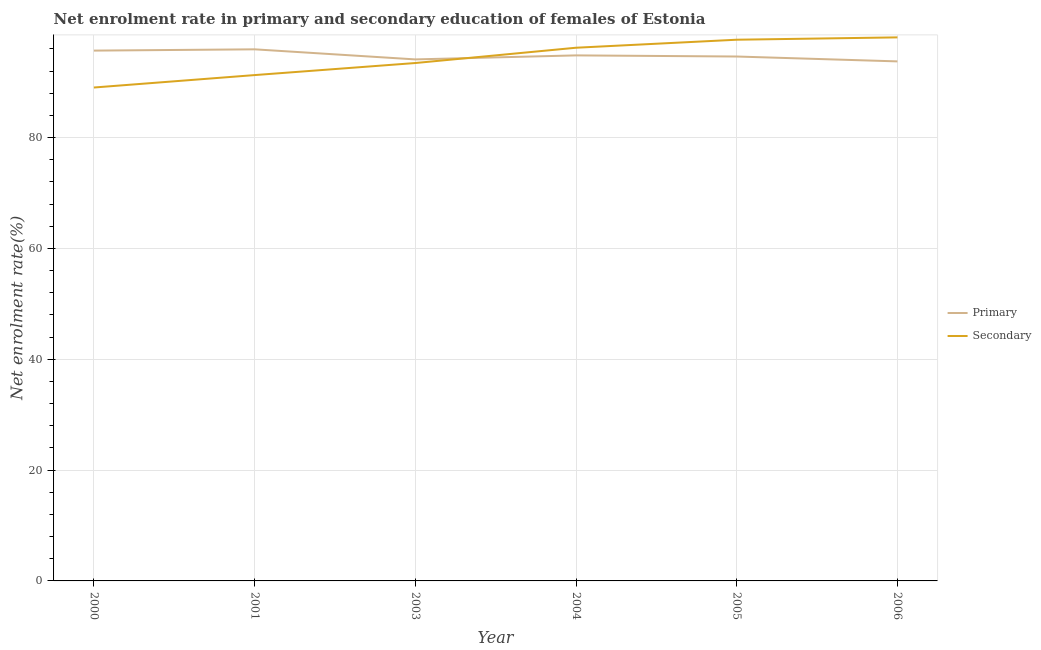How many different coloured lines are there?
Offer a terse response. 2. What is the enrollment rate in secondary education in 2004?
Give a very brief answer. 96.22. Across all years, what is the maximum enrollment rate in primary education?
Your response must be concise. 95.94. Across all years, what is the minimum enrollment rate in secondary education?
Your response must be concise. 89.04. In which year was the enrollment rate in secondary education minimum?
Offer a terse response. 2000. What is the total enrollment rate in secondary education in the graph?
Your response must be concise. 565.78. What is the difference between the enrollment rate in primary education in 2001 and that in 2003?
Offer a very short reply. 1.82. What is the difference between the enrollment rate in primary education in 2004 and the enrollment rate in secondary education in 2003?
Your response must be concise. 1.38. What is the average enrollment rate in primary education per year?
Your response must be concise. 94.83. In the year 2001, what is the difference between the enrollment rate in primary education and enrollment rate in secondary education?
Make the answer very short. 4.65. In how many years, is the enrollment rate in secondary education greater than 48 %?
Keep it short and to the point. 6. What is the ratio of the enrollment rate in secondary education in 2001 to that in 2004?
Your answer should be compact. 0.95. What is the difference between the highest and the second highest enrollment rate in primary education?
Provide a succinct answer. 0.23. What is the difference between the highest and the lowest enrollment rate in secondary education?
Keep it short and to the point. 9.05. In how many years, is the enrollment rate in secondary education greater than the average enrollment rate in secondary education taken over all years?
Keep it short and to the point. 3. Does the enrollment rate in primary education monotonically increase over the years?
Your answer should be very brief. No. Is the enrollment rate in primary education strictly greater than the enrollment rate in secondary education over the years?
Give a very brief answer. No. How many lines are there?
Your answer should be very brief. 2. How many years are there in the graph?
Your answer should be compact. 6. Does the graph contain any zero values?
Make the answer very short. No. Does the graph contain grids?
Your answer should be compact. Yes. How many legend labels are there?
Provide a succinct answer. 2. What is the title of the graph?
Your answer should be very brief. Net enrolment rate in primary and secondary education of females of Estonia. Does "Electricity" appear as one of the legend labels in the graph?
Your answer should be compact. No. What is the label or title of the X-axis?
Your answer should be compact. Year. What is the label or title of the Y-axis?
Make the answer very short. Net enrolment rate(%). What is the Net enrolment rate(%) in Primary in 2000?
Your answer should be very brief. 95.7. What is the Net enrolment rate(%) of Secondary in 2000?
Your answer should be very brief. 89.04. What is the Net enrolment rate(%) of Primary in 2001?
Offer a very short reply. 95.94. What is the Net enrolment rate(%) of Secondary in 2001?
Your answer should be compact. 91.29. What is the Net enrolment rate(%) in Primary in 2003?
Give a very brief answer. 94.12. What is the Net enrolment rate(%) in Secondary in 2003?
Keep it short and to the point. 93.46. What is the Net enrolment rate(%) in Primary in 2004?
Ensure brevity in your answer.  94.84. What is the Net enrolment rate(%) in Secondary in 2004?
Offer a terse response. 96.22. What is the Net enrolment rate(%) in Primary in 2005?
Make the answer very short. 94.64. What is the Net enrolment rate(%) of Secondary in 2005?
Keep it short and to the point. 97.67. What is the Net enrolment rate(%) of Primary in 2006?
Offer a terse response. 93.76. What is the Net enrolment rate(%) of Secondary in 2006?
Provide a short and direct response. 98.09. Across all years, what is the maximum Net enrolment rate(%) in Primary?
Your answer should be very brief. 95.94. Across all years, what is the maximum Net enrolment rate(%) in Secondary?
Give a very brief answer. 98.09. Across all years, what is the minimum Net enrolment rate(%) of Primary?
Offer a terse response. 93.76. Across all years, what is the minimum Net enrolment rate(%) in Secondary?
Your response must be concise. 89.04. What is the total Net enrolment rate(%) in Primary in the graph?
Provide a short and direct response. 569. What is the total Net enrolment rate(%) in Secondary in the graph?
Give a very brief answer. 565.78. What is the difference between the Net enrolment rate(%) of Primary in 2000 and that in 2001?
Ensure brevity in your answer.  -0.23. What is the difference between the Net enrolment rate(%) of Secondary in 2000 and that in 2001?
Your answer should be very brief. -2.24. What is the difference between the Net enrolment rate(%) of Primary in 2000 and that in 2003?
Your answer should be very brief. 1.59. What is the difference between the Net enrolment rate(%) of Secondary in 2000 and that in 2003?
Your answer should be compact. -4.42. What is the difference between the Net enrolment rate(%) in Primary in 2000 and that in 2004?
Ensure brevity in your answer.  0.86. What is the difference between the Net enrolment rate(%) of Secondary in 2000 and that in 2004?
Provide a succinct answer. -7.18. What is the difference between the Net enrolment rate(%) in Primary in 2000 and that in 2005?
Offer a very short reply. 1.07. What is the difference between the Net enrolment rate(%) of Secondary in 2000 and that in 2005?
Ensure brevity in your answer.  -8.63. What is the difference between the Net enrolment rate(%) of Primary in 2000 and that in 2006?
Your answer should be very brief. 1.94. What is the difference between the Net enrolment rate(%) of Secondary in 2000 and that in 2006?
Offer a terse response. -9.05. What is the difference between the Net enrolment rate(%) in Primary in 2001 and that in 2003?
Offer a terse response. 1.82. What is the difference between the Net enrolment rate(%) of Secondary in 2001 and that in 2003?
Make the answer very short. -2.18. What is the difference between the Net enrolment rate(%) in Primary in 2001 and that in 2004?
Offer a terse response. 1.09. What is the difference between the Net enrolment rate(%) in Secondary in 2001 and that in 2004?
Make the answer very short. -4.94. What is the difference between the Net enrolment rate(%) in Primary in 2001 and that in 2005?
Give a very brief answer. 1.3. What is the difference between the Net enrolment rate(%) of Secondary in 2001 and that in 2005?
Your response must be concise. -6.38. What is the difference between the Net enrolment rate(%) of Primary in 2001 and that in 2006?
Keep it short and to the point. 2.18. What is the difference between the Net enrolment rate(%) of Secondary in 2001 and that in 2006?
Your answer should be very brief. -6.8. What is the difference between the Net enrolment rate(%) of Primary in 2003 and that in 2004?
Your response must be concise. -0.73. What is the difference between the Net enrolment rate(%) of Secondary in 2003 and that in 2004?
Make the answer very short. -2.76. What is the difference between the Net enrolment rate(%) in Primary in 2003 and that in 2005?
Offer a very short reply. -0.52. What is the difference between the Net enrolment rate(%) of Secondary in 2003 and that in 2005?
Your answer should be very brief. -4.21. What is the difference between the Net enrolment rate(%) of Primary in 2003 and that in 2006?
Offer a terse response. 0.36. What is the difference between the Net enrolment rate(%) of Secondary in 2003 and that in 2006?
Ensure brevity in your answer.  -4.63. What is the difference between the Net enrolment rate(%) in Primary in 2004 and that in 2005?
Keep it short and to the point. 0.2. What is the difference between the Net enrolment rate(%) of Secondary in 2004 and that in 2005?
Provide a short and direct response. -1.45. What is the difference between the Net enrolment rate(%) in Primary in 2004 and that in 2006?
Provide a short and direct response. 1.08. What is the difference between the Net enrolment rate(%) in Secondary in 2004 and that in 2006?
Offer a terse response. -1.87. What is the difference between the Net enrolment rate(%) of Primary in 2005 and that in 2006?
Keep it short and to the point. 0.88. What is the difference between the Net enrolment rate(%) of Secondary in 2005 and that in 2006?
Your response must be concise. -0.42. What is the difference between the Net enrolment rate(%) in Primary in 2000 and the Net enrolment rate(%) in Secondary in 2001?
Offer a terse response. 4.42. What is the difference between the Net enrolment rate(%) in Primary in 2000 and the Net enrolment rate(%) in Secondary in 2003?
Your answer should be compact. 2.24. What is the difference between the Net enrolment rate(%) in Primary in 2000 and the Net enrolment rate(%) in Secondary in 2004?
Give a very brief answer. -0.52. What is the difference between the Net enrolment rate(%) in Primary in 2000 and the Net enrolment rate(%) in Secondary in 2005?
Keep it short and to the point. -1.97. What is the difference between the Net enrolment rate(%) in Primary in 2000 and the Net enrolment rate(%) in Secondary in 2006?
Give a very brief answer. -2.39. What is the difference between the Net enrolment rate(%) of Primary in 2001 and the Net enrolment rate(%) of Secondary in 2003?
Provide a succinct answer. 2.47. What is the difference between the Net enrolment rate(%) in Primary in 2001 and the Net enrolment rate(%) in Secondary in 2004?
Your answer should be very brief. -0.29. What is the difference between the Net enrolment rate(%) of Primary in 2001 and the Net enrolment rate(%) of Secondary in 2005?
Offer a terse response. -1.73. What is the difference between the Net enrolment rate(%) of Primary in 2001 and the Net enrolment rate(%) of Secondary in 2006?
Offer a very short reply. -2.15. What is the difference between the Net enrolment rate(%) of Primary in 2003 and the Net enrolment rate(%) of Secondary in 2004?
Offer a very short reply. -2.11. What is the difference between the Net enrolment rate(%) of Primary in 2003 and the Net enrolment rate(%) of Secondary in 2005?
Make the answer very short. -3.55. What is the difference between the Net enrolment rate(%) in Primary in 2003 and the Net enrolment rate(%) in Secondary in 2006?
Ensure brevity in your answer.  -3.97. What is the difference between the Net enrolment rate(%) in Primary in 2004 and the Net enrolment rate(%) in Secondary in 2005?
Provide a succinct answer. -2.83. What is the difference between the Net enrolment rate(%) of Primary in 2004 and the Net enrolment rate(%) of Secondary in 2006?
Your response must be concise. -3.25. What is the difference between the Net enrolment rate(%) of Primary in 2005 and the Net enrolment rate(%) of Secondary in 2006?
Provide a short and direct response. -3.45. What is the average Net enrolment rate(%) of Primary per year?
Make the answer very short. 94.83. What is the average Net enrolment rate(%) of Secondary per year?
Keep it short and to the point. 94.3. In the year 2000, what is the difference between the Net enrolment rate(%) of Primary and Net enrolment rate(%) of Secondary?
Offer a terse response. 6.66. In the year 2001, what is the difference between the Net enrolment rate(%) in Primary and Net enrolment rate(%) in Secondary?
Your answer should be very brief. 4.65. In the year 2003, what is the difference between the Net enrolment rate(%) in Primary and Net enrolment rate(%) in Secondary?
Ensure brevity in your answer.  0.65. In the year 2004, what is the difference between the Net enrolment rate(%) of Primary and Net enrolment rate(%) of Secondary?
Keep it short and to the point. -1.38. In the year 2005, what is the difference between the Net enrolment rate(%) of Primary and Net enrolment rate(%) of Secondary?
Ensure brevity in your answer.  -3.03. In the year 2006, what is the difference between the Net enrolment rate(%) in Primary and Net enrolment rate(%) in Secondary?
Offer a very short reply. -4.33. What is the ratio of the Net enrolment rate(%) in Primary in 2000 to that in 2001?
Offer a terse response. 1. What is the ratio of the Net enrolment rate(%) of Secondary in 2000 to that in 2001?
Your response must be concise. 0.98. What is the ratio of the Net enrolment rate(%) in Primary in 2000 to that in 2003?
Your answer should be very brief. 1.02. What is the ratio of the Net enrolment rate(%) in Secondary in 2000 to that in 2003?
Provide a short and direct response. 0.95. What is the ratio of the Net enrolment rate(%) of Primary in 2000 to that in 2004?
Provide a short and direct response. 1.01. What is the ratio of the Net enrolment rate(%) of Secondary in 2000 to that in 2004?
Your response must be concise. 0.93. What is the ratio of the Net enrolment rate(%) of Primary in 2000 to that in 2005?
Provide a short and direct response. 1.01. What is the ratio of the Net enrolment rate(%) of Secondary in 2000 to that in 2005?
Make the answer very short. 0.91. What is the ratio of the Net enrolment rate(%) of Primary in 2000 to that in 2006?
Offer a very short reply. 1.02. What is the ratio of the Net enrolment rate(%) of Secondary in 2000 to that in 2006?
Make the answer very short. 0.91. What is the ratio of the Net enrolment rate(%) in Primary in 2001 to that in 2003?
Your answer should be compact. 1.02. What is the ratio of the Net enrolment rate(%) of Secondary in 2001 to that in 2003?
Provide a succinct answer. 0.98. What is the ratio of the Net enrolment rate(%) of Primary in 2001 to that in 2004?
Your response must be concise. 1.01. What is the ratio of the Net enrolment rate(%) of Secondary in 2001 to that in 2004?
Offer a very short reply. 0.95. What is the ratio of the Net enrolment rate(%) of Primary in 2001 to that in 2005?
Your response must be concise. 1.01. What is the ratio of the Net enrolment rate(%) in Secondary in 2001 to that in 2005?
Make the answer very short. 0.93. What is the ratio of the Net enrolment rate(%) in Primary in 2001 to that in 2006?
Give a very brief answer. 1.02. What is the ratio of the Net enrolment rate(%) in Secondary in 2001 to that in 2006?
Offer a very short reply. 0.93. What is the ratio of the Net enrolment rate(%) of Secondary in 2003 to that in 2004?
Ensure brevity in your answer.  0.97. What is the ratio of the Net enrolment rate(%) of Primary in 2003 to that in 2005?
Provide a succinct answer. 0.99. What is the ratio of the Net enrolment rate(%) of Secondary in 2003 to that in 2005?
Provide a succinct answer. 0.96. What is the ratio of the Net enrolment rate(%) in Primary in 2003 to that in 2006?
Give a very brief answer. 1. What is the ratio of the Net enrolment rate(%) of Secondary in 2003 to that in 2006?
Give a very brief answer. 0.95. What is the ratio of the Net enrolment rate(%) in Primary in 2004 to that in 2005?
Your answer should be very brief. 1. What is the ratio of the Net enrolment rate(%) in Secondary in 2004 to that in 2005?
Provide a succinct answer. 0.99. What is the ratio of the Net enrolment rate(%) in Primary in 2004 to that in 2006?
Your answer should be very brief. 1.01. What is the ratio of the Net enrolment rate(%) in Primary in 2005 to that in 2006?
Your response must be concise. 1.01. What is the difference between the highest and the second highest Net enrolment rate(%) in Primary?
Keep it short and to the point. 0.23. What is the difference between the highest and the second highest Net enrolment rate(%) in Secondary?
Make the answer very short. 0.42. What is the difference between the highest and the lowest Net enrolment rate(%) of Primary?
Give a very brief answer. 2.18. What is the difference between the highest and the lowest Net enrolment rate(%) of Secondary?
Give a very brief answer. 9.05. 